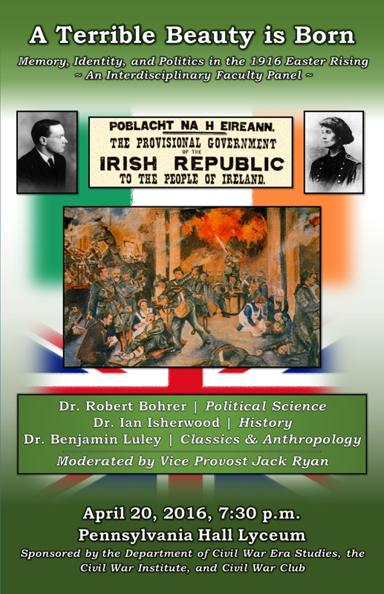What is the topic of the interdisciplinary faculty panel? The topic of the interdisciplinary faculty panel is titled 'A Terrible Beauty is Born: Memory, Identity, and Politics in the 1916 Easter Rising.' This panel focuses on a critical examination of how the Easter Rising influenced Irish national identity, memory, and the political landscape. 